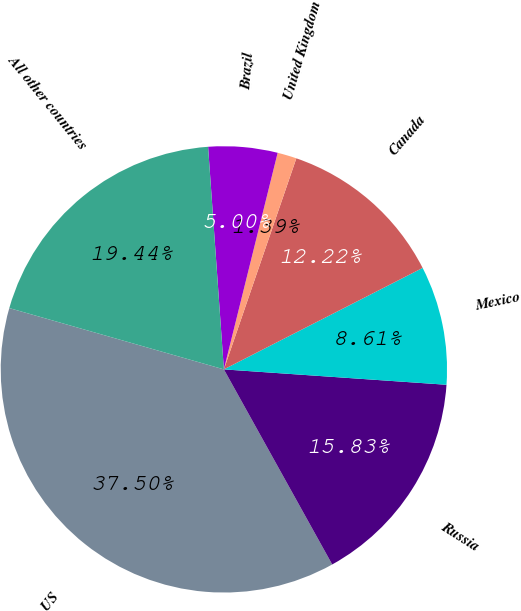Convert chart. <chart><loc_0><loc_0><loc_500><loc_500><pie_chart><fcel>US<fcel>Russia<fcel>Mexico<fcel>Canada<fcel>United Kingdom<fcel>Brazil<fcel>All other countries<nl><fcel>37.49%<fcel>15.83%<fcel>8.61%<fcel>12.22%<fcel>1.39%<fcel>5.0%<fcel>19.44%<nl></chart> 